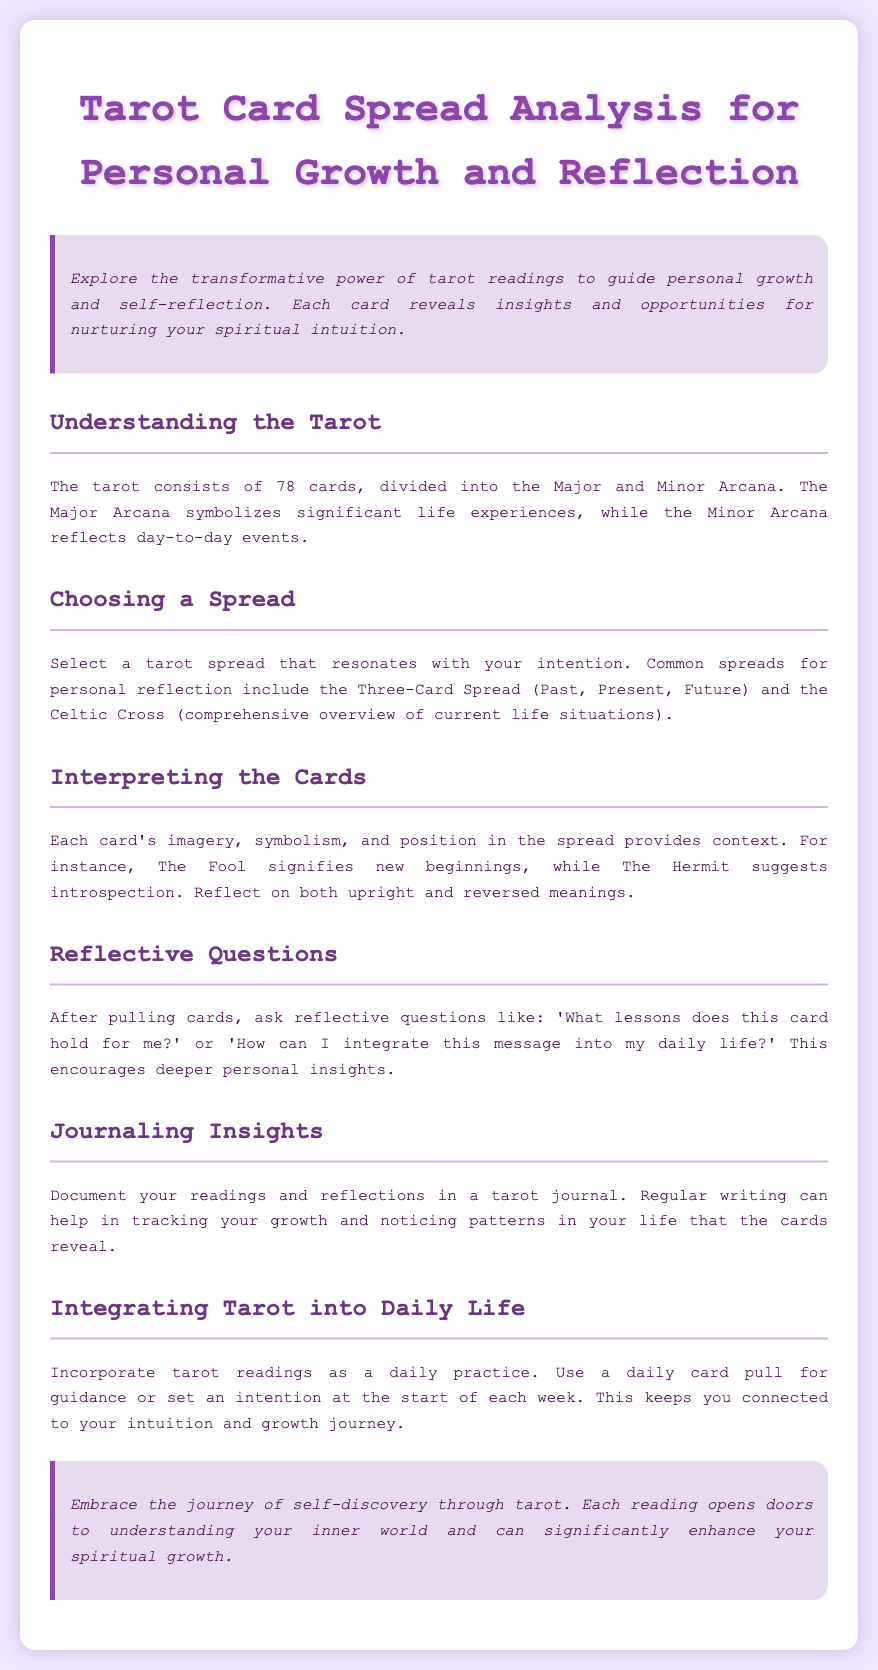what is the total number of tarot cards? The document states there are 78 cards in the tarot.
Answer: 78 what are the two main divisions of tarot cards? The document mentions the Major and Minor Arcana as the divisions.
Answer: Major and Minor Arcana what spread is suggested for a comprehensive overview? The document recommends the Celtic Cross for a comprehensive overview of life situations.
Answer: Celtic Cross what does The Fool card signify? The document indicates that The Fool signifies new beginnings.
Answer: new beginnings what type of questions should you ask after pulling cards? The document provides examples of reflective questions like 'What lessons does this card hold for me?'
Answer: reflective questions how can journaling benefit your tarot practice? The document states that journaling helps in tracking growth and noticing patterns.
Answer: tracking growth how is tarot recommended to be integrated into daily life? The document suggests incorporating daily card pulls for guidance.
Answer: daily card pulls what is the purpose of interpreting cards in a spread? The document explains that interpreting cards provides context based on imagery and positioning.
Answer: provides context what does the document suggest for the first step in tarot? The document mentions "Choosing a Spread" as the first step in tarot reading.
Answer: Choosing a Spread what benefit does the document mention regarding self-discovery through tarot? The document states that tarot can significantly enhance your spiritual growth.
Answer: spiritual growth 